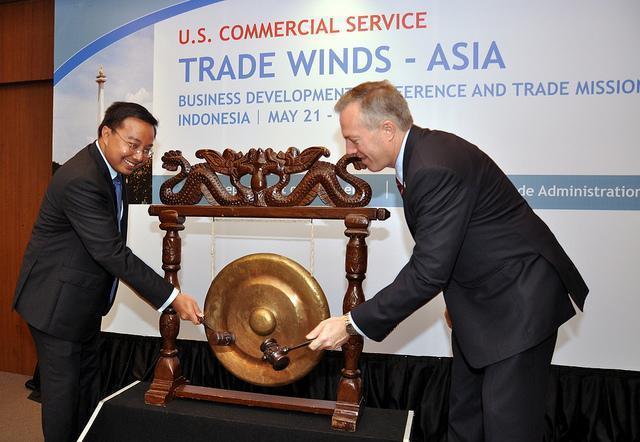What does hitting the gong here signal?
Make your selection and explain in format: 'Answer: answer
Rationale: rationale.'
Options: Opening, divorce, parity, grievance. Answer: opening.
Rationale: Gongs are commonly used as ceremonial instruments. 